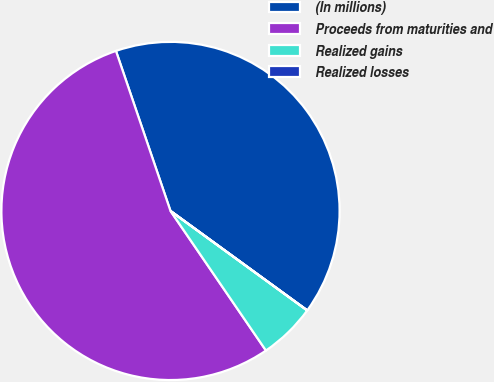Convert chart. <chart><loc_0><loc_0><loc_500><loc_500><pie_chart><fcel>(In millions)<fcel>Proceeds from maturities and<fcel>Realized gains<fcel>Realized losses<nl><fcel>40.23%<fcel>54.32%<fcel>5.44%<fcel>0.01%<nl></chart> 